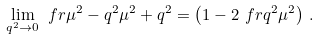Convert formula to latex. <formula><loc_0><loc_0><loc_500><loc_500>\lim _ { q ^ { 2 } \rightarrow 0 } \ f r { \mu ^ { 2 } - q ^ { 2 } } { \mu ^ { 2 } + q ^ { 2 } } = \left ( 1 - 2 \ f r { q ^ { 2 } } { \mu ^ { 2 } } \right ) \, .</formula> 